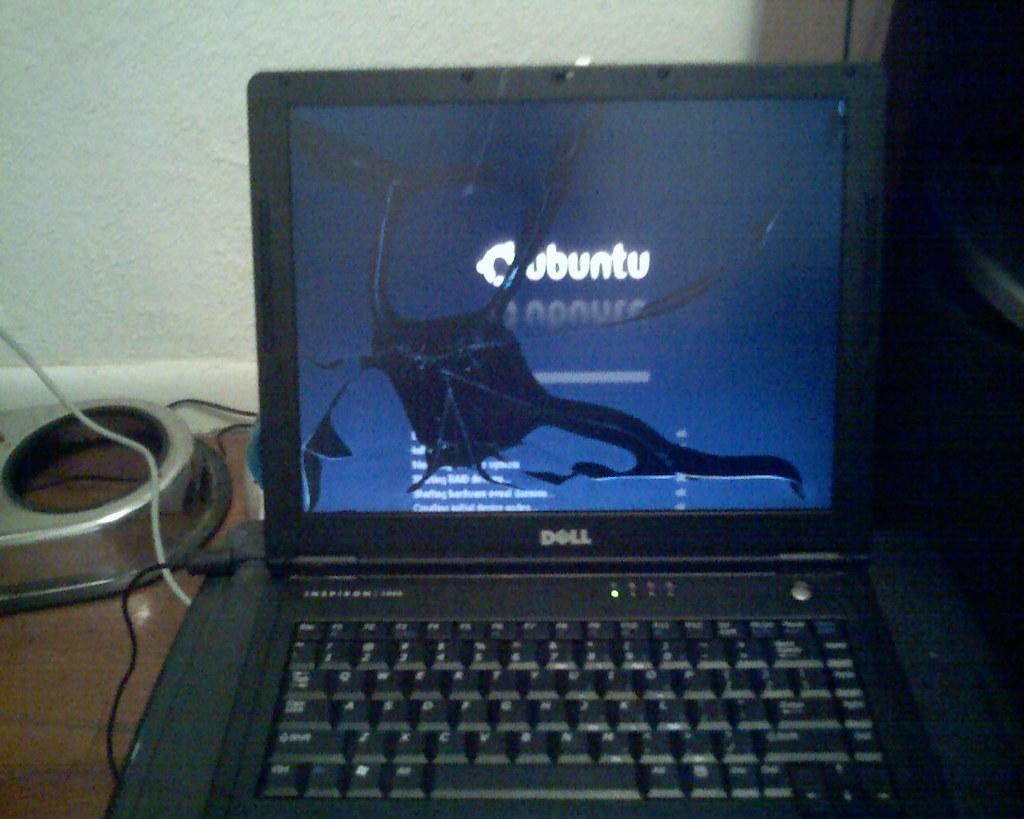<image>
Describe the image concisely. A Dell laptop with a cracked screen is showing a blue screen with the word Cubuntu on it. 